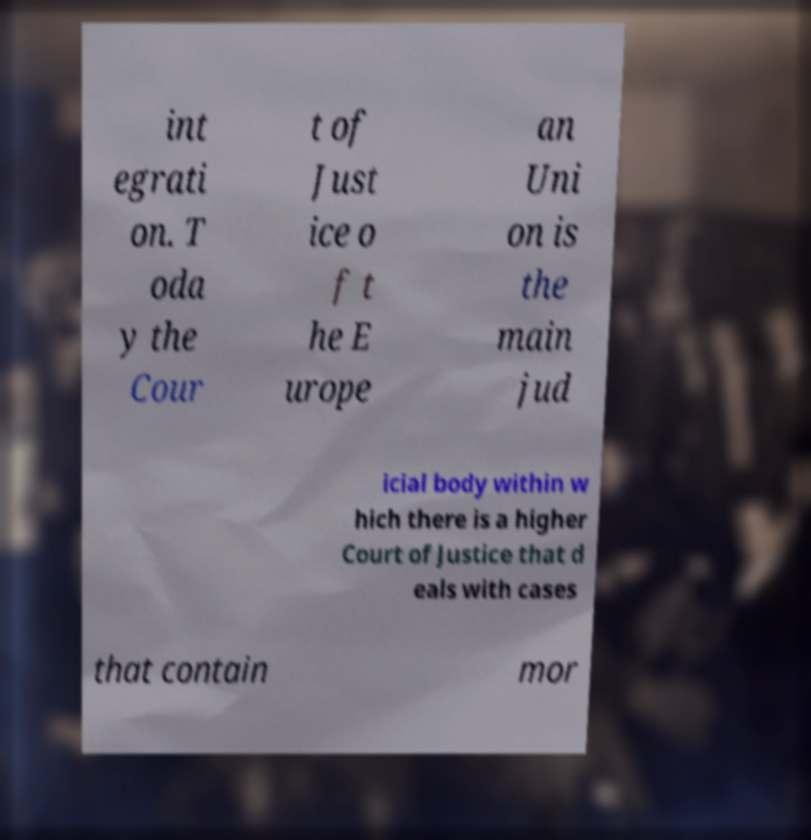Could you assist in decoding the text presented in this image and type it out clearly? int egrati on. T oda y the Cour t of Just ice o f t he E urope an Uni on is the main jud icial body within w hich there is a higher Court of Justice that d eals with cases that contain mor 